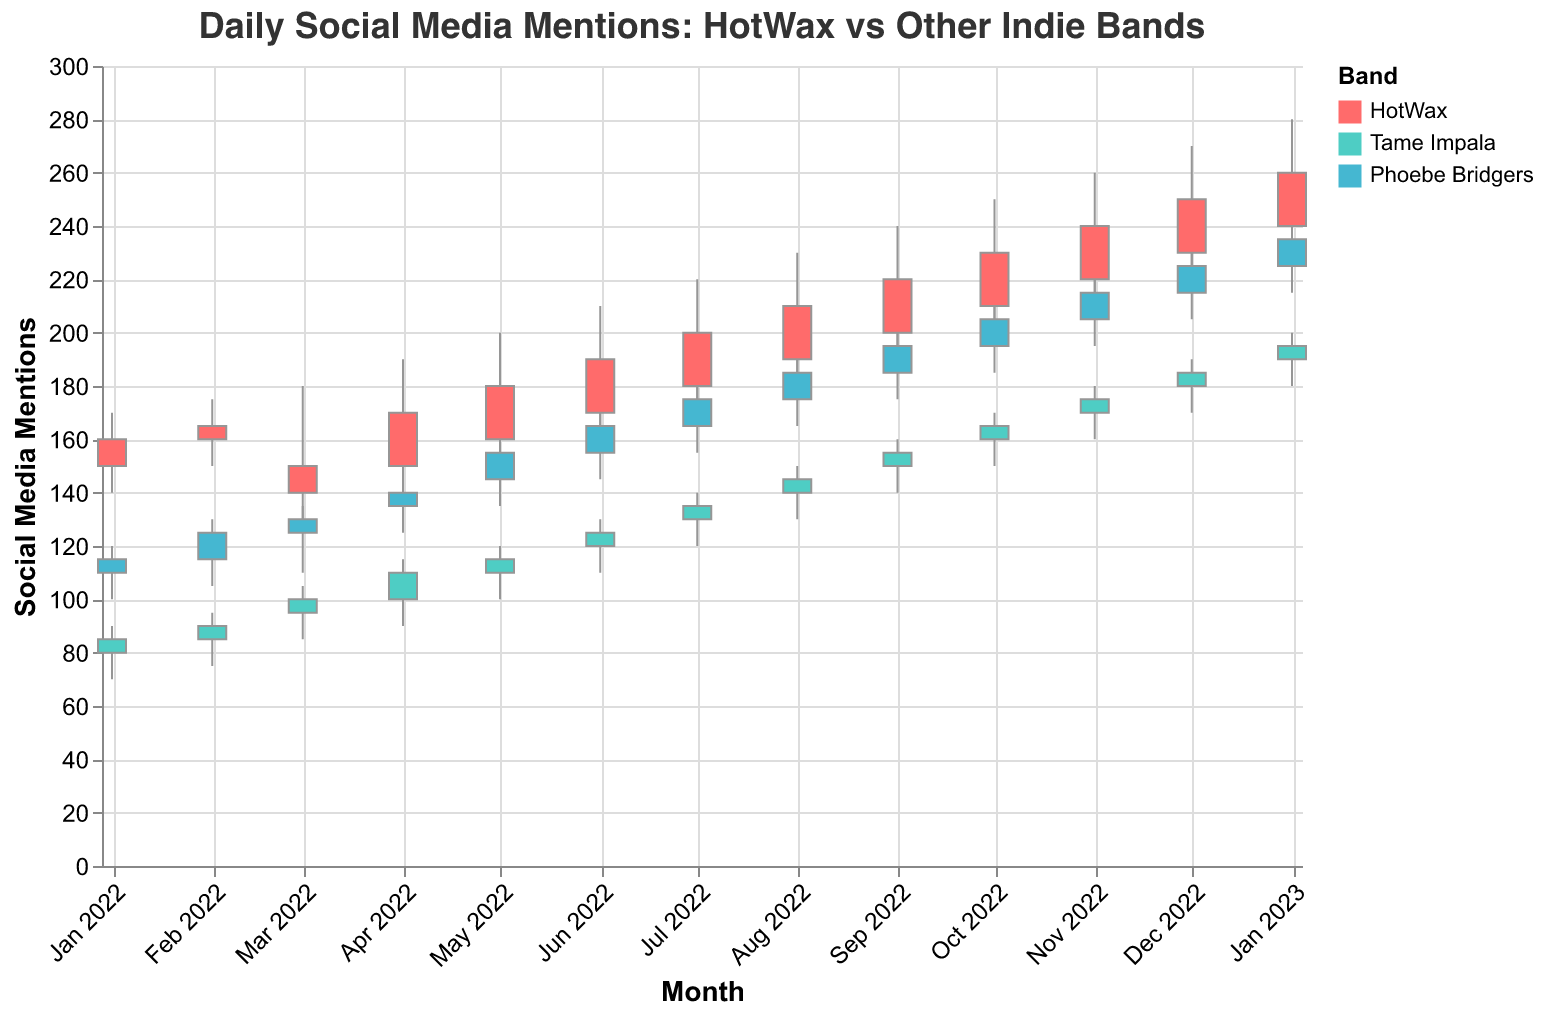What is the highest number of daily mentions for HotWax in the period shown? To find the highest number of daily mentions for HotWax, look for the highest value on the vertical axis corresponding to the "High" value for HotWax. This value is 280 in January 2023.
Answer: 280 How does the number of social media mentions for HotWax in January 2023 compare to Tame Impala in the same month? For January 2023, the "Close" value for HotWax is 260, and for Tame Impala, it is 195. Comparing these shows that HotWax had more mentions than Tame Impala in January 2023.
Answer: HotWax had more mentions Which band had the lowest "Low" value and what was it? Look at the "Low" values for all bands throughout the year. The lowest "Low" value is 70 for Tame Impala in January 2022.
Answer: Tame Impala, 70 Between which months did HotWax see the largest increase in "Close" value? Compare the "Close" values month-to-month for HotWax. The largest increase is from August 2022 (210) to September 2022 (220), an increase of 10 mentions.
Answer: August to September 2022 What is the average "Close" value for Phoebe Bridgers over the period shown? Sum the "Close" values for Phoebe Bridgers and divide by the number of months. The "Close" values are 115, 125, 130, 140, 155, 165, 175, 185, 195, 205, 215, 225, 235. Sum: 2260. Divide by 13: 173.85
Answer: 173.85 In which month did HotWax first surpass 200 daily mentions? Check the "Close" values for HotWax each month. The first month HotWax surpasses 200 mentions is in August 2022 with a "Close" value of 210.
Answer: August 2022 Which band had the most stable mentions over the year, and how can you tell? Compare the range (High-Low) for each band over the months. A smaller range indicates more stability. Tame Impala typically has the smallest ranges in their High-Low values.
Answer: Tame Impala How did social media mentions for Phoebe Bridgers change from February 2022 to March 2022? The "Close" value for Phoebe Bridgers in February 2022 was 125 and in March 2022 it was 130. This indicates an increase of 5 mentions.
Answer: Increased by 5 Which month saw the highest volatility for HotWax and what were the values? Volatility can be measured by the range (High-Low). The highest range for HotWax is in December 2022, with a High of 270 and a Low of 220, giving a range of 50.
Answer: December 2022, range of 50 